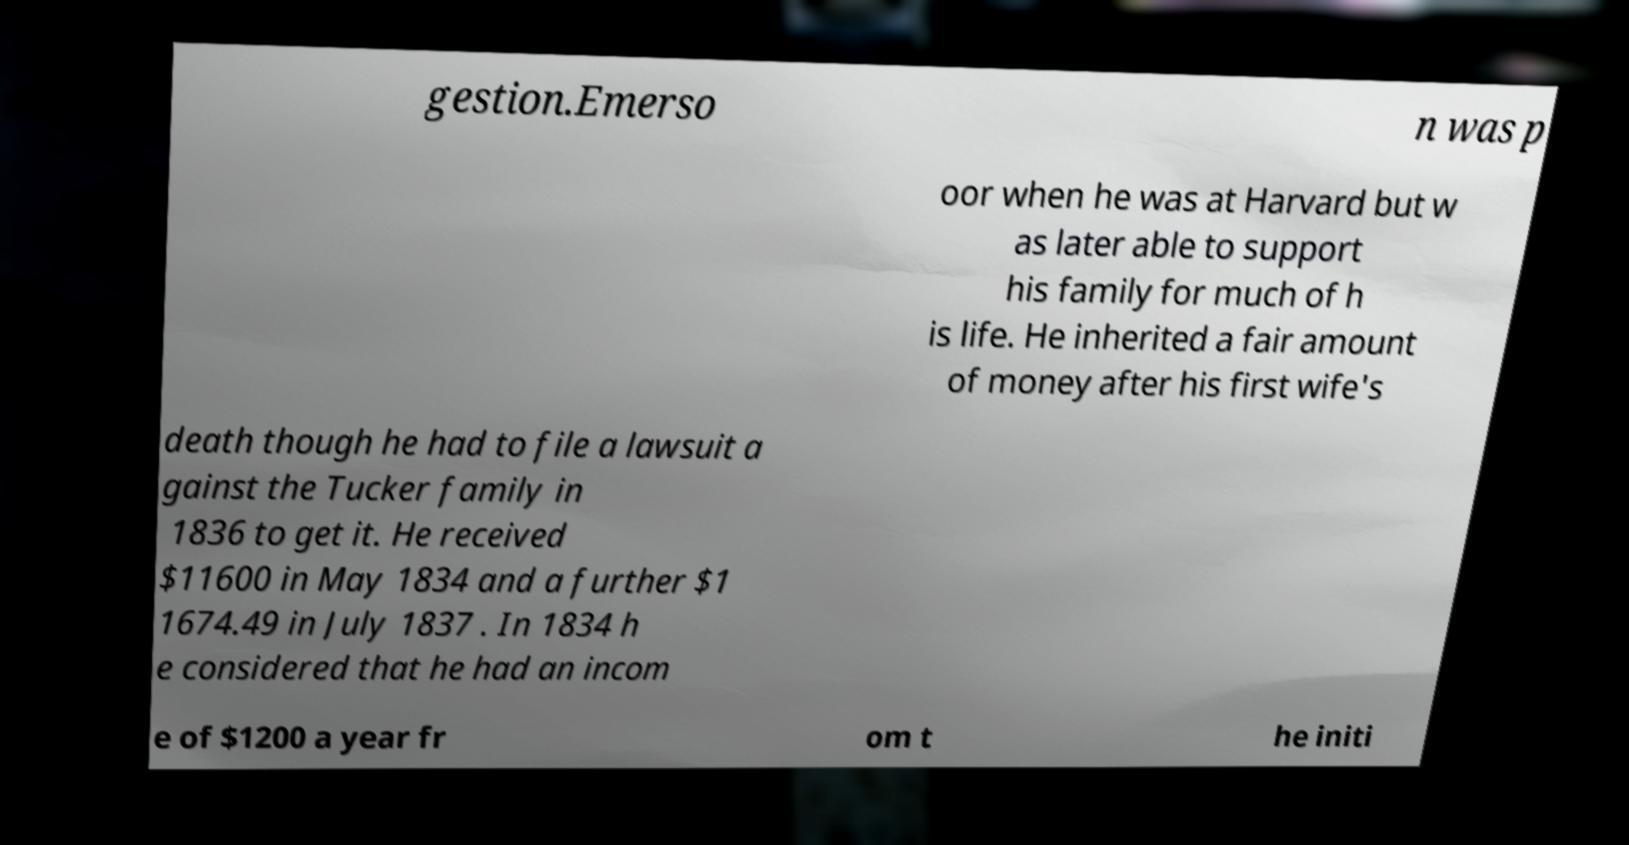For documentation purposes, I need the text within this image transcribed. Could you provide that? gestion.Emerso n was p oor when he was at Harvard but w as later able to support his family for much of h is life. He inherited a fair amount of money after his first wife's death though he had to file a lawsuit a gainst the Tucker family in 1836 to get it. He received $11600 in May 1834 and a further $1 1674.49 in July 1837 . In 1834 h e considered that he had an incom e of $1200 a year fr om t he initi 